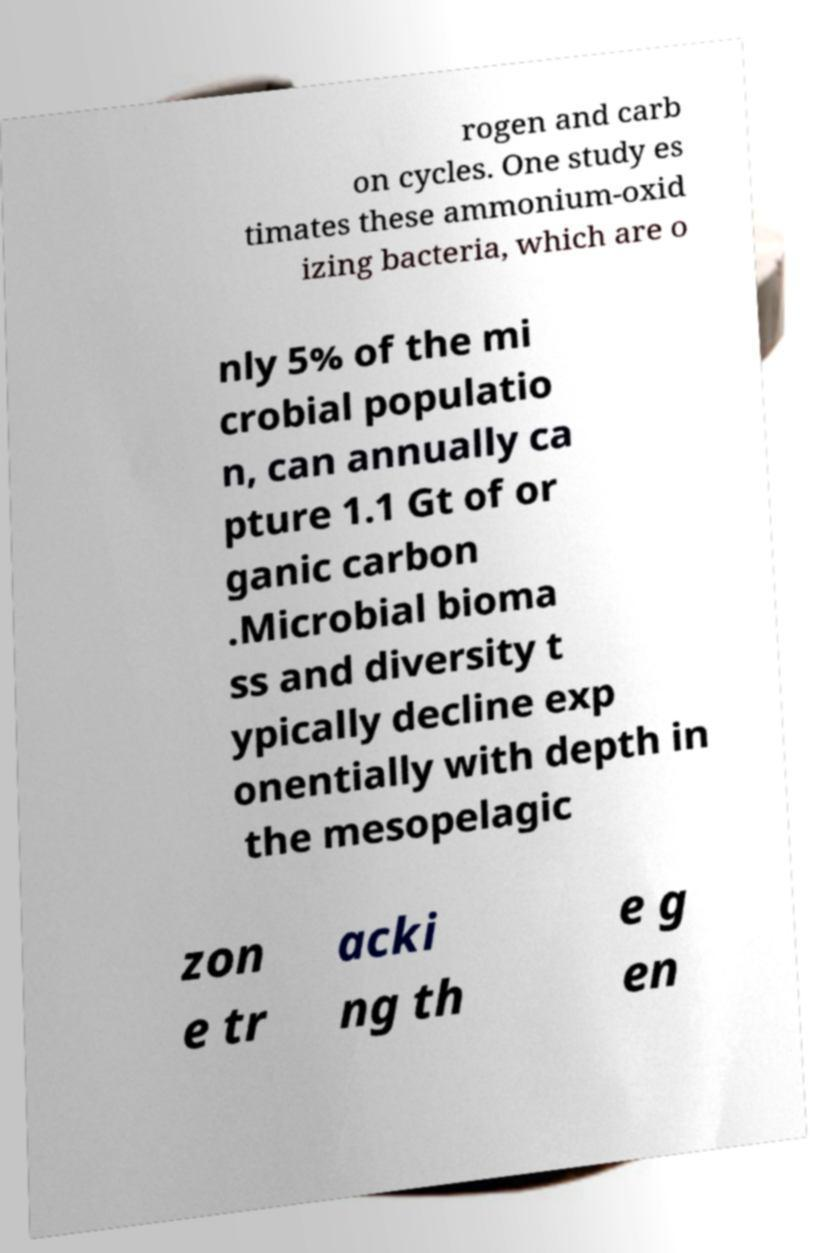Could you extract and type out the text from this image? rogen and carb on cycles. One study es timates these ammonium-oxid izing bacteria, which are o nly 5% of the mi crobial populatio n, can annually ca pture 1.1 Gt of or ganic carbon .Microbial bioma ss and diversity t ypically decline exp onentially with depth in the mesopelagic zon e tr acki ng th e g en 